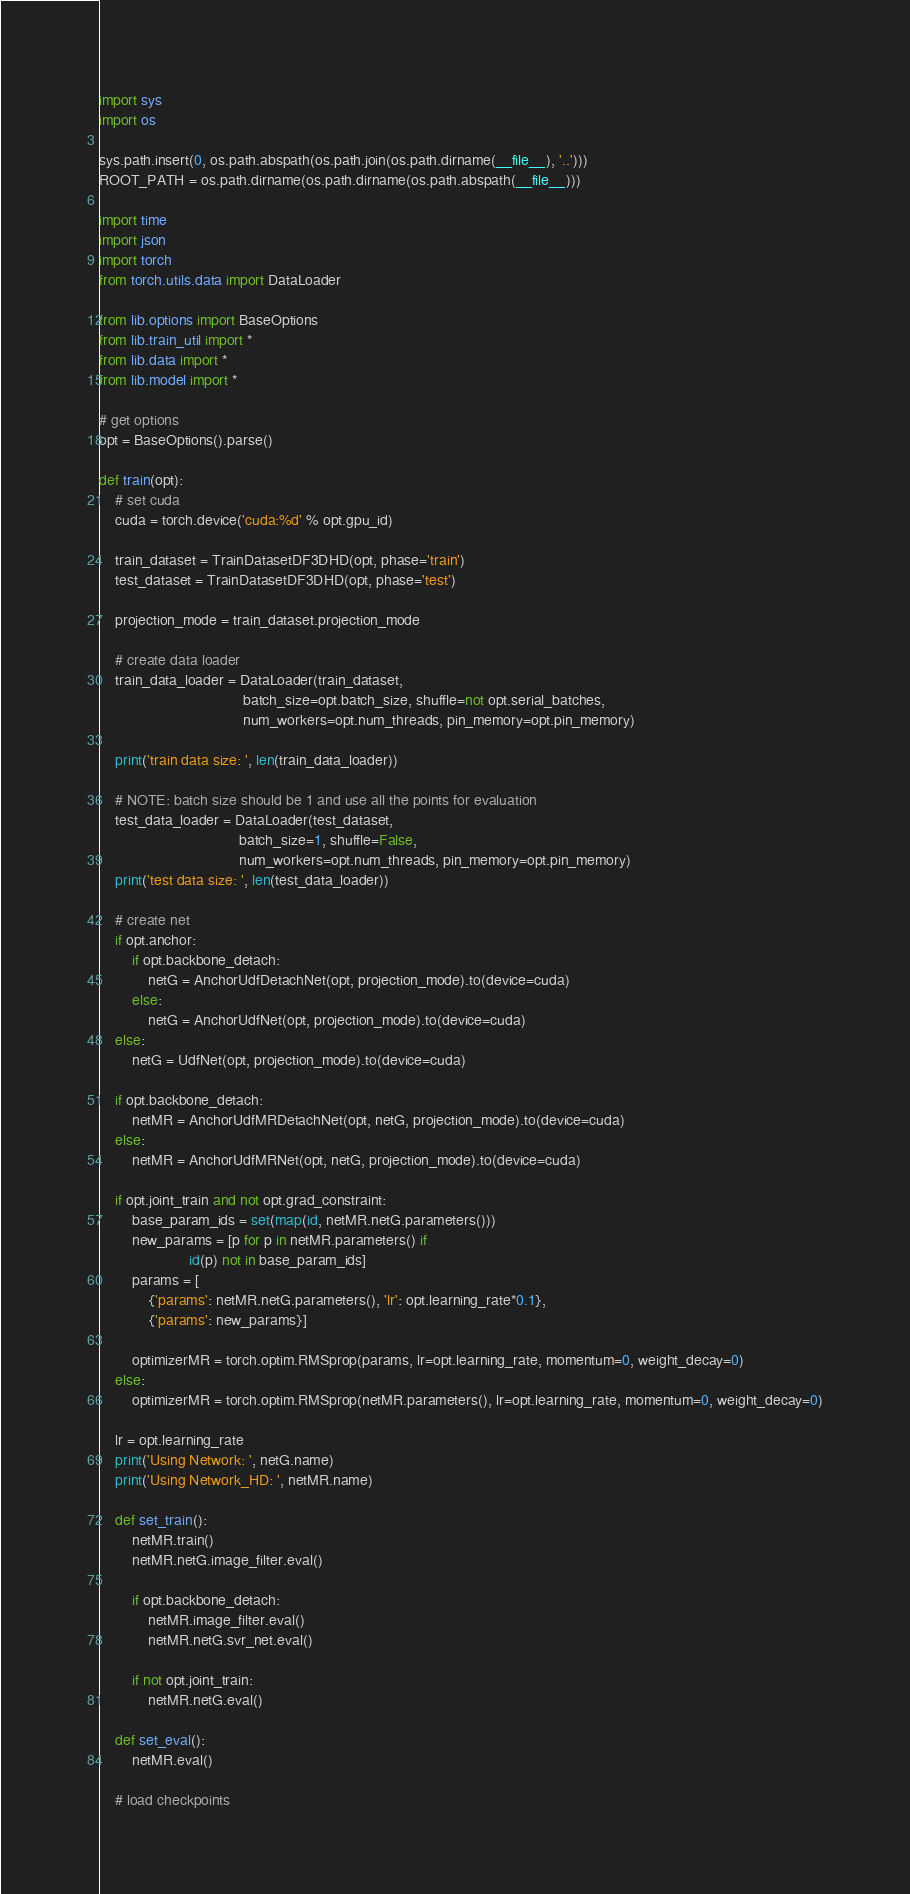Convert code to text. <code><loc_0><loc_0><loc_500><loc_500><_Python_>import sys
import os

sys.path.insert(0, os.path.abspath(os.path.join(os.path.dirname(__file__), '..')))
ROOT_PATH = os.path.dirname(os.path.dirname(os.path.abspath(__file__)))

import time
import json
import torch
from torch.utils.data import DataLoader

from lib.options import BaseOptions
from lib.train_util import *
from lib.data import *
from lib.model import *

# get options
opt = BaseOptions().parse()

def train(opt):
    # set cuda
    cuda = torch.device('cuda:%d' % opt.gpu_id)

    train_dataset = TrainDatasetDF3DHD(opt, phase='train')
    test_dataset = TrainDatasetDF3DHD(opt, phase='test')

    projection_mode = train_dataset.projection_mode

    # create data loader
    train_data_loader = DataLoader(train_dataset,
                                   batch_size=opt.batch_size, shuffle=not opt.serial_batches,
                                   num_workers=opt.num_threads, pin_memory=opt.pin_memory)

    print('train data size: ', len(train_data_loader))

    # NOTE: batch size should be 1 and use all the points for evaluation
    test_data_loader = DataLoader(test_dataset,
                                  batch_size=1, shuffle=False,
                                  num_workers=opt.num_threads, pin_memory=opt.pin_memory)
    print('test data size: ', len(test_data_loader))

    # create net
    if opt.anchor:
        if opt.backbone_detach:
            netG = AnchorUdfDetachNet(opt, projection_mode).to(device=cuda)
        else:
            netG = AnchorUdfNet(opt, projection_mode).to(device=cuda)
    else:
        netG = UdfNet(opt, projection_mode).to(device=cuda)

    if opt.backbone_detach:
        netMR = AnchorUdfMRDetachNet(opt, netG, projection_mode).to(device=cuda)
    else:
        netMR = AnchorUdfMRNet(opt, netG, projection_mode).to(device=cuda)

    if opt.joint_train and not opt.grad_constraint:
        base_param_ids = set(map(id, netMR.netG.parameters()))
        new_params = [p for p in netMR.parameters() if
                      id(p) not in base_param_ids]
        params = [
            {'params': netMR.netG.parameters(), 'lr': opt.learning_rate*0.1},
            {'params': new_params}]

        optimizerMR = torch.optim.RMSprop(params, lr=opt.learning_rate, momentum=0, weight_decay=0)
    else:
        optimizerMR = torch.optim.RMSprop(netMR.parameters(), lr=opt.learning_rate, momentum=0, weight_decay=0)

    lr = opt.learning_rate
    print('Using Network: ', netG.name)
    print('Using Network_HD: ', netMR.name)
    
    def set_train():
        netMR.train()
        netMR.netG.image_filter.eval()

        if opt.backbone_detach:
            netMR.image_filter.eval()
            netMR.netG.svr_net.eval()

        if not opt.joint_train:
            netMR.netG.eval()

    def set_eval():
        netMR.eval()

    # load checkpoints</code> 